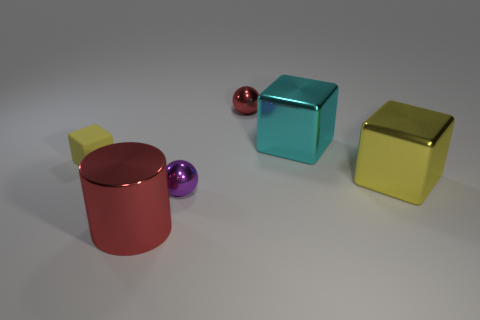Is there anything else that is the same shape as the big red object?
Keep it short and to the point. No. Are there any other things that are made of the same material as the tiny yellow cube?
Keep it short and to the point. No. What is the color of the other large cube that is made of the same material as the big yellow cube?
Provide a short and direct response. Cyan. Is there a yellow metal object that has the same size as the cyan cube?
Your response must be concise. Yes. The red shiny thing that is the same size as the matte object is what shape?
Provide a succinct answer. Sphere. Is there another large metallic thing of the same shape as the cyan thing?
Make the answer very short. Yes. Does the cyan block have the same material as the yellow thing right of the purple object?
Offer a very short reply. Yes. Is there a metallic object that has the same color as the small matte cube?
Offer a terse response. Yes. What number of other objects are the same material as the big red object?
Keep it short and to the point. 4. Do the big shiny cylinder and the tiny object behind the small yellow block have the same color?
Your answer should be compact. Yes. 